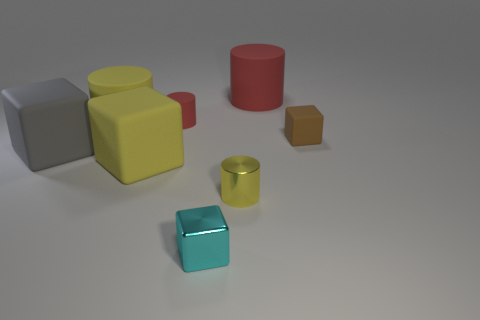Add 1 large cubes. How many objects exist? 9 Subtract all big purple matte cylinders. Subtract all big red objects. How many objects are left? 7 Add 7 gray matte blocks. How many gray matte blocks are left? 8 Add 2 large yellow things. How many large yellow things exist? 4 Subtract 0 cyan spheres. How many objects are left? 8 